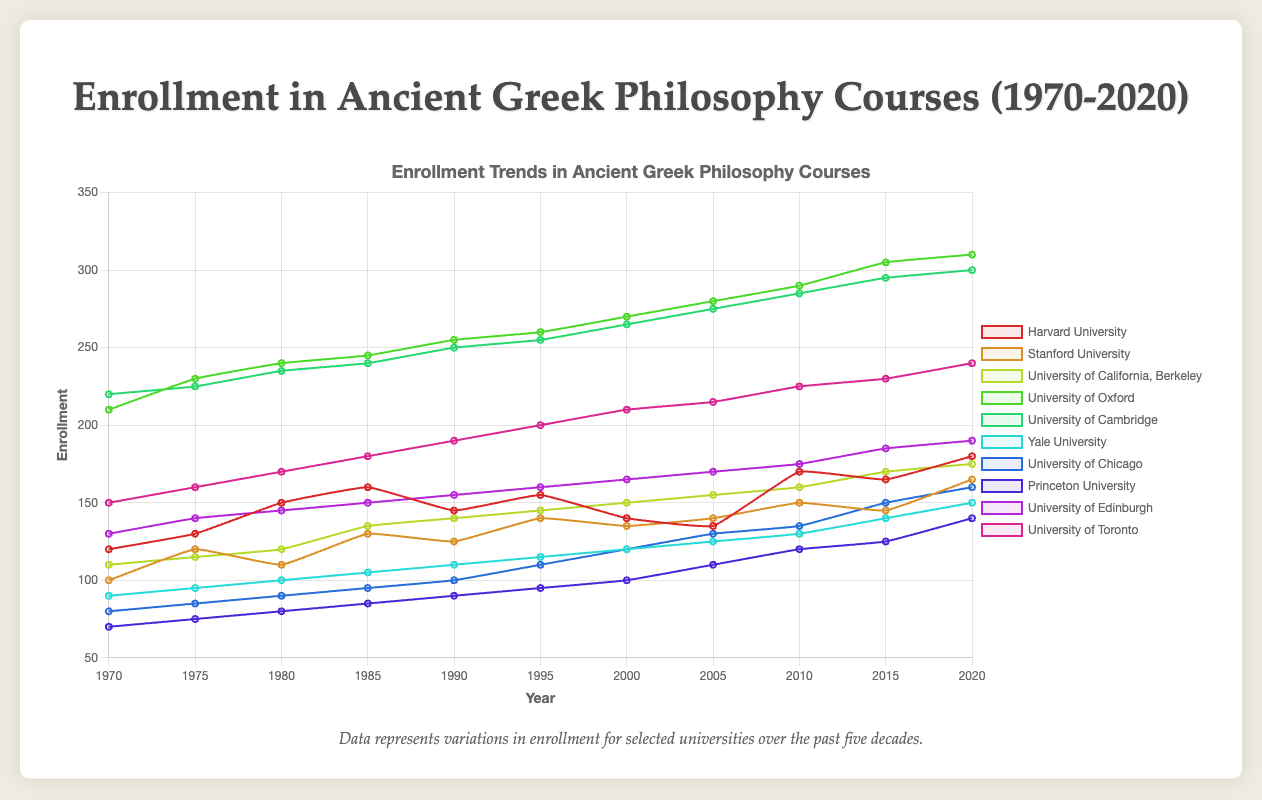What are the years when Harvard University and Yale University had equal enrollments, and what were those enrollments? Identify the enrollment values for Harvard University (green line) and Yale University (red line) across the years. Find the year(s) when these two lines intersect.
Answer: 2010, enrollment was 130 Which university had the highest enrollment in 2020, and what was the value? Look at the end of each line, corresponding to the year 2020. Find the line that is highest, indicating the institution with the highest enrollment.
Answer: University of Oxford, 310 Between 1970 and 1980, which university experienced the largest increase in enrollment and by how much? Determine the enrollment for each university in 1970 and 1980. Subtract the 1970 values from the 1980 values to find the differences and identify the largest difference.
Answer: University of Oxford, 30 Which university showed a consistent increase in enrollment every recorded year? Observe each line on the plot for consistency in upward movement from 1970 to 2020, with no year showing a decline in enrollment.
Answer: University of Toronto In which year did Stanford University have its lowest enrollment between 1970 and 2020, and what was the value? Examine Stanford University’s data points (blue line) and identify the lowest point and note the corresponding year and value.
Answer: 1980, 110 What is the average enrollment for Princeton University over the recorded years? Sum the enrollment values from 1970 to 2020 for Princeton University, then divide by the number of recorded years (11).
Answer: (70 + 75 + 80 + 85 + 90 + 95 + 100 + 110 + 120 + 125 + 140)/11 = 99.55 In 1995, which university had the highest enrollment, and what was the value? Compare the enrollment values of all universities in 1995 and identify the maximum value and the respective university.
Answer: University of Cambridge, 255 Which two universities had enrollments closest to each other in 2015, and what was the difference between their enrollments? Find the enrollment values for all universities in 2015 and calculate the absolute differences between each pair. Identify the pair with the smallest difference.
Answer: Harvard University and Stanford University, 20 What is the trend in enrollment for the University of Chicago over the decades? Observe the general direction (upward, downward, or stagnating) of the University of Chicago’s enrollment data points (gold line) from the 1970s to 2020.
Answer: Generally upward Which university had a maximum dip in enrollment between any two consecutive years, and what was the dip? Calculate differences of enrollments between consecutive years for each university to identify the maximum dip.
Answer: Harvard University from 1985 to 1990, 15 